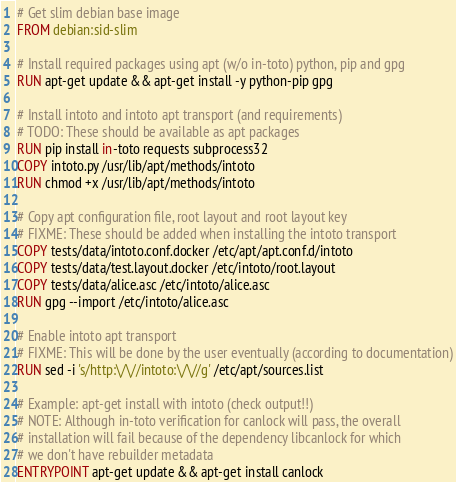<code> <loc_0><loc_0><loc_500><loc_500><_Dockerfile_># Get slim debian base image
FROM debian:sid-slim

# Install required packages using apt (w/o in-toto) python, pip and gpg
RUN apt-get update && apt-get install -y python-pip gpg

# Install intoto and intoto apt transport (and requirements)
# TODO: These should be available as apt packages
RUN pip install in-toto requests subprocess32
COPY intoto.py /usr/lib/apt/methods/intoto
RUN chmod +x /usr/lib/apt/methods/intoto

# Copy apt configuration file, root layout and root layout key
# FIXME: These should be added when installing the intoto transport
COPY tests/data/intoto.conf.docker /etc/apt/apt.conf.d/intoto
COPY tests/data/test.layout.docker /etc/intoto/root.layout
COPY tests/data/alice.asc /etc/intoto/alice.asc
RUN gpg --import /etc/intoto/alice.asc

# Enable intoto apt transport
# FIXME: This will be done by the user eventually (according to documentation)
RUN sed -i 's/http:\/\//intoto:\/\//g' /etc/apt/sources.list

# Example: apt-get install with intoto (check output!!)
# NOTE: Although in-toto verification for canlock will pass, the overall
# installation will fail because of the dependency libcanlock for which
# we don't have rebuilder metadata
ENTRYPOINT apt-get update && apt-get install canlock
</code> 